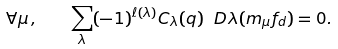Convert formula to latex. <formula><loc_0><loc_0><loc_500><loc_500>\forall \mu \, , \quad \sum _ { \lambda } ( - 1 ) ^ { \ell ( \lambda ) } C _ { \lambda } ( q ) \ D \lambda ( m _ { \mu } f _ { d } ) = 0 .</formula> 